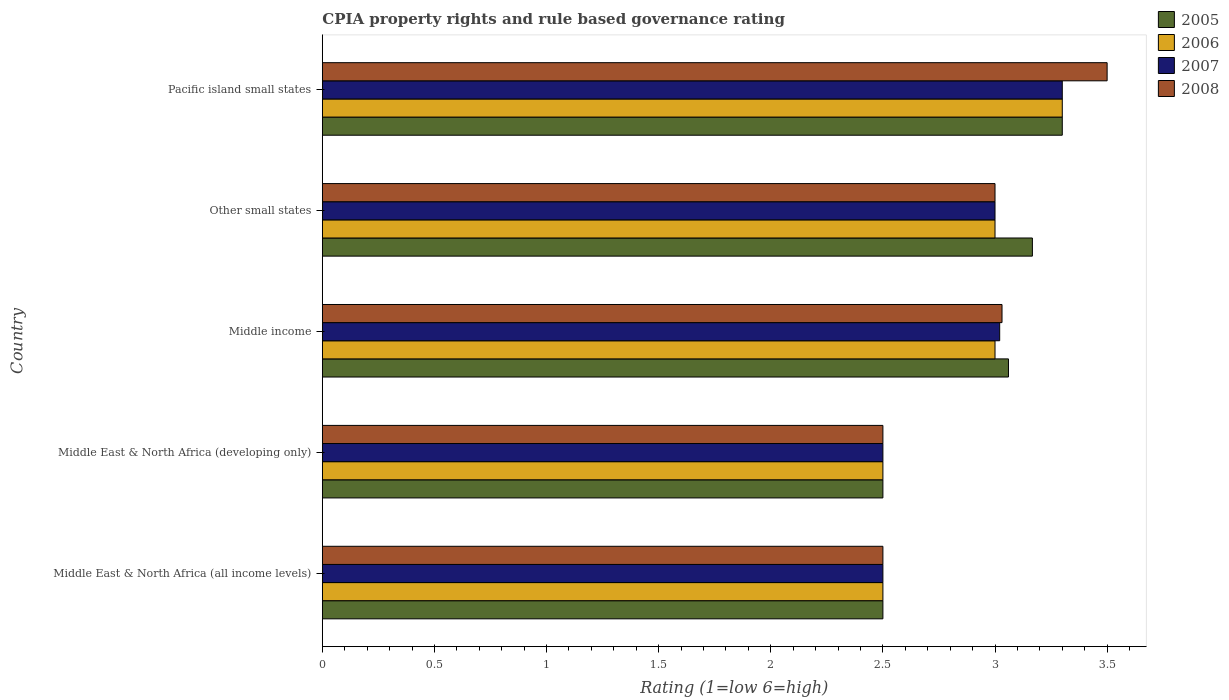How many groups of bars are there?
Your response must be concise. 5. Are the number of bars per tick equal to the number of legend labels?
Your answer should be very brief. Yes. How many bars are there on the 4th tick from the bottom?
Your response must be concise. 4. What is the label of the 3rd group of bars from the top?
Offer a terse response. Middle income. In how many cases, is the number of bars for a given country not equal to the number of legend labels?
Your response must be concise. 0. What is the CPIA rating in 2005 in Middle East & North Africa (developing only)?
Your response must be concise. 2.5. In which country was the CPIA rating in 2005 maximum?
Offer a terse response. Pacific island small states. In which country was the CPIA rating in 2006 minimum?
Provide a short and direct response. Middle East & North Africa (all income levels). What is the total CPIA rating in 2005 in the graph?
Offer a very short reply. 14.53. What is the average CPIA rating in 2007 per country?
Give a very brief answer. 2.86. In how many countries, is the CPIA rating in 2005 greater than 1.3 ?
Provide a short and direct response. 5. What is the ratio of the CPIA rating in 2008 in Middle East & North Africa (developing only) to that in Pacific island small states?
Make the answer very short. 0.71. What is the difference between the highest and the second highest CPIA rating in 2006?
Offer a terse response. 0.3. What is the difference between the highest and the lowest CPIA rating in 2006?
Your answer should be very brief. 0.8. Are the values on the major ticks of X-axis written in scientific E-notation?
Ensure brevity in your answer.  No. Does the graph contain any zero values?
Provide a succinct answer. No. How are the legend labels stacked?
Ensure brevity in your answer.  Vertical. What is the title of the graph?
Your answer should be compact. CPIA property rights and rule based governance rating. What is the label or title of the X-axis?
Make the answer very short. Rating (1=low 6=high). What is the Rating (1=low 6=high) in 2007 in Middle East & North Africa (all income levels)?
Offer a very short reply. 2.5. What is the Rating (1=low 6=high) in 2005 in Middle East & North Africa (developing only)?
Your response must be concise. 2.5. What is the Rating (1=low 6=high) of 2006 in Middle East & North Africa (developing only)?
Make the answer very short. 2.5. What is the Rating (1=low 6=high) in 2008 in Middle East & North Africa (developing only)?
Provide a short and direct response. 2.5. What is the Rating (1=low 6=high) of 2005 in Middle income?
Provide a short and direct response. 3.06. What is the Rating (1=low 6=high) of 2006 in Middle income?
Keep it short and to the point. 3. What is the Rating (1=low 6=high) of 2007 in Middle income?
Give a very brief answer. 3.02. What is the Rating (1=low 6=high) of 2008 in Middle income?
Your response must be concise. 3.03. What is the Rating (1=low 6=high) in 2005 in Other small states?
Provide a succinct answer. 3.17. What is the Rating (1=low 6=high) in 2006 in Other small states?
Provide a succinct answer. 3. What is the Rating (1=low 6=high) of 2007 in Other small states?
Keep it short and to the point. 3. What is the Rating (1=low 6=high) in 2006 in Pacific island small states?
Your answer should be compact. 3.3. Across all countries, what is the maximum Rating (1=low 6=high) of 2005?
Provide a succinct answer. 3.3. Across all countries, what is the maximum Rating (1=low 6=high) of 2006?
Your answer should be very brief. 3.3. Across all countries, what is the minimum Rating (1=low 6=high) of 2005?
Offer a very short reply. 2.5. Across all countries, what is the minimum Rating (1=low 6=high) in 2006?
Your answer should be very brief. 2.5. Across all countries, what is the minimum Rating (1=low 6=high) of 2008?
Make the answer very short. 2.5. What is the total Rating (1=low 6=high) of 2005 in the graph?
Provide a succinct answer. 14.53. What is the total Rating (1=low 6=high) of 2006 in the graph?
Keep it short and to the point. 14.3. What is the total Rating (1=low 6=high) in 2007 in the graph?
Offer a terse response. 14.32. What is the total Rating (1=low 6=high) in 2008 in the graph?
Your answer should be compact. 14.53. What is the difference between the Rating (1=low 6=high) in 2005 in Middle East & North Africa (all income levels) and that in Middle East & North Africa (developing only)?
Give a very brief answer. 0. What is the difference between the Rating (1=low 6=high) of 2006 in Middle East & North Africa (all income levels) and that in Middle East & North Africa (developing only)?
Provide a short and direct response. 0. What is the difference between the Rating (1=low 6=high) of 2008 in Middle East & North Africa (all income levels) and that in Middle East & North Africa (developing only)?
Make the answer very short. 0. What is the difference between the Rating (1=low 6=high) of 2005 in Middle East & North Africa (all income levels) and that in Middle income?
Provide a short and direct response. -0.56. What is the difference between the Rating (1=low 6=high) in 2006 in Middle East & North Africa (all income levels) and that in Middle income?
Offer a very short reply. -0.5. What is the difference between the Rating (1=low 6=high) in 2007 in Middle East & North Africa (all income levels) and that in Middle income?
Keep it short and to the point. -0.52. What is the difference between the Rating (1=low 6=high) in 2008 in Middle East & North Africa (all income levels) and that in Middle income?
Offer a terse response. -0.53. What is the difference between the Rating (1=low 6=high) in 2008 in Middle East & North Africa (all income levels) and that in Other small states?
Provide a short and direct response. -0.5. What is the difference between the Rating (1=low 6=high) in 2006 in Middle East & North Africa (all income levels) and that in Pacific island small states?
Offer a terse response. -0.8. What is the difference between the Rating (1=low 6=high) of 2007 in Middle East & North Africa (all income levels) and that in Pacific island small states?
Provide a succinct answer. -0.8. What is the difference between the Rating (1=low 6=high) in 2008 in Middle East & North Africa (all income levels) and that in Pacific island small states?
Offer a terse response. -1. What is the difference between the Rating (1=low 6=high) of 2005 in Middle East & North Africa (developing only) and that in Middle income?
Your answer should be very brief. -0.56. What is the difference between the Rating (1=low 6=high) of 2007 in Middle East & North Africa (developing only) and that in Middle income?
Your answer should be very brief. -0.52. What is the difference between the Rating (1=low 6=high) in 2008 in Middle East & North Africa (developing only) and that in Middle income?
Keep it short and to the point. -0.53. What is the difference between the Rating (1=low 6=high) in 2005 in Middle East & North Africa (developing only) and that in Other small states?
Ensure brevity in your answer.  -0.67. What is the difference between the Rating (1=low 6=high) in 2006 in Middle East & North Africa (developing only) and that in Other small states?
Your answer should be very brief. -0.5. What is the difference between the Rating (1=low 6=high) in 2007 in Middle East & North Africa (developing only) and that in Other small states?
Keep it short and to the point. -0.5. What is the difference between the Rating (1=low 6=high) in 2006 in Middle East & North Africa (developing only) and that in Pacific island small states?
Give a very brief answer. -0.8. What is the difference between the Rating (1=low 6=high) in 2008 in Middle East & North Africa (developing only) and that in Pacific island small states?
Provide a succinct answer. -1. What is the difference between the Rating (1=low 6=high) of 2005 in Middle income and that in Other small states?
Provide a short and direct response. -0.11. What is the difference between the Rating (1=low 6=high) of 2007 in Middle income and that in Other small states?
Offer a very short reply. 0.02. What is the difference between the Rating (1=low 6=high) of 2008 in Middle income and that in Other small states?
Offer a terse response. 0.03. What is the difference between the Rating (1=low 6=high) in 2005 in Middle income and that in Pacific island small states?
Offer a very short reply. -0.24. What is the difference between the Rating (1=low 6=high) of 2007 in Middle income and that in Pacific island small states?
Offer a very short reply. -0.28. What is the difference between the Rating (1=low 6=high) of 2008 in Middle income and that in Pacific island small states?
Make the answer very short. -0.47. What is the difference between the Rating (1=low 6=high) of 2005 in Other small states and that in Pacific island small states?
Your response must be concise. -0.13. What is the difference between the Rating (1=low 6=high) in 2008 in Other small states and that in Pacific island small states?
Your response must be concise. -0.5. What is the difference between the Rating (1=low 6=high) in 2005 in Middle East & North Africa (all income levels) and the Rating (1=low 6=high) in 2006 in Middle East & North Africa (developing only)?
Keep it short and to the point. 0. What is the difference between the Rating (1=low 6=high) in 2005 in Middle East & North Africa (all income levels) and the Rating (1=low 6=high) in 2008 in Middle East & North Africa (developing only)?
Offer a terse response. 0. What is the difference between the Rating (1=low 6=high) in 2006 in Middle East & North Africa (all income levels) and the Rating (1=low 6=high) in 2007 in Middle East & North Africa (developing only)?
Your answer should be compact. 0. What is the difference between the Rating (1=low 6=high) in 2006 in Middle East & North Africa (all income levels) and the Rating (1=low 6=high) in 2008 in Middle East & North Africa (developing only)?
Your response must be concise. 0. What is the difference between the Rating (1=low 6=high) of 2007 in Middle East & North Africa (all income levels) and the Rating (1=low 6=high) of 2008 in Middle East & North Africa (developing only)?
Give a very brief answer. 0. What is the difference between the Rating (1=low 6=high) of 2005 in Middle East & North Africa (all income levels) and the Rating (1=low 6=high) of 2007 in Middle income?
Your answer should be very brief. -0.52. What is the difference between the Rating (1=low 6=high) of 2005 in Middle East & North Africa (all income levels) and the Rating (1=low 6=high) of 2008 in Middle income?
Offer a terse response. -0.53. What is the difference between the Rating (1=low 6=high) of 2006 in Middle East & North Africa (all income levels) and the Rating (1=low 6=high) of 2007 in Middle income?
Your answer should be very brief. -0.52. What is the difference between the Rating (1=low 6=high) of 2006 in Middle East & North Africa (all income levels) and the Rating (1=low 6=high) of 2008 in Middle income?
Offer a very short reply. -0.53. What is the difference between the Rating (1=low 6=high) in 2007 in Middle East & North Africa (all income levels) and the Rating (1=low 6=high) in 2008 in Middle income?
Your answer should be very brief. -0.53. What is the difference between the Rating (1=low 6=high) of 2005 in Middle East & North Africa (all income levels) and the Rating (1=low 6=high) of 2006 in Other small states?
Your answer should be very brief. -0.5. What is the difference between the Rating (1=low 6=high) in 2005 in Middle East & North Africa (all income levels) and the Rating (1=low 6=high) in 2008 in Other small states?
Ensure brevity in your answer.  -0.5. What is the difference between the Rating (1=low 6=high) of 2006 in Middle East & North Africa (all income levels) and the Rating (1=low 6=high) of 2007 in Other small states?
Offer a terse response. -0.5. What is the difference between the Rating (1=low 6=high) in 2006 in Middle East & North Africa (all income levels) and the Rating (1=low 6=high) in 2008 in Other small states?
Your answer should be very brief. -0.5. What is the difference between the Rating (1=low 6=high) in 2005 in Middle East & North Africa (all income levels) and the Rating (1=low 6=high) in 2007 in Pacific island small states?
Offer a very short reply. -0.8. What is the difference between the Rating (1=low 6=high) in 2005 in Middle East & North Africa (all income levels) and the Rating (1=low 6=high) in 2008 in Pacific island small states?
Offer a very short reply. -1. What is the difference between the Rating (1=low 6=high) in 2006 in Middle East & North Africa (all income levels) and the Rating (1=low 6=high) in 2008 in Pacific island small states?
Keep it short and to the point. -1. What is the difference between the Rating (1=low 6=high) in 2005 in Middle East & North Africa (developing only) and the Rating (1=low 6=high) in 2006 in Middle income?
Provide a short and direct response. -0.5. What is the difference between the Rating (1=low 6=high) in 2005 in Middle East & North Africa (developing only) and the Rating (1=low 6=high) in 2007 in Middle income?
Offer a terse response. -0.52. What is the difference between the Rating (1=low 6=high) of 2005 in Middle East & North Africa (developing only) and the Rating (1=low 6=high) of 2008 in Middle income?
Offer a very short reply. -0.53. What is the difference between the Rating (1=low 6=high) of 2006 in Middle East & North Africa (developing only) and the Rating (1=low 6=high) of 2007 in Middle income?
Keep it short and to the point. -0.52. What is the difference between the Rating (1=low 6=high) in 2006 in Middle East & North Africa (developing only) and the Rating (1=low 6=high) in 2008 in Middle income?
Your response must be concise. -0.53. What is the difference between the Rating (1=low 6=high) in 2007 in Middle East & North Africa (developing only) and the Rating (1=low 6=high) in 2008 in Middle income?
Make the answer very short. -0.53. What is the difference between the Rating (1=low 6=high) of 2006 in Middle East & North Africa (developing only) and the Rating (1=low 6=high) of 2007 in Other small states?
Your response must be concise. -0.5. What is the difference between the Rating (1=low 6=high) of 2005 in Middle East & North Africa (developing only) and the Rating (1=low 6=high) of 2006 in Pacific island small states?
Give a very brief answer. -0.8. What is the difference between the Rating (1=low 6=high) in 2005 in Middle East & North Africa (developing only) and the Rating (1=low 6=high) in 2007 in Pacific island small states?
Keep it short and to the point. -0.8. What is the difference between the Rating (1=low 6=high) of 2006 in Middle East & North Africa (developing only) and the Rating (1=low 6=high) of 2008 in Pacific island small states?
Provide a short and direct response. -1. What is the difference between the Rating (1=low 6=high) of 2005 in Middle income and the Rating (1=low 6=high) of 2008 in Other small states?
Give a very brief answer. 0.06. What is the difference between the Rating (1=low 6=high) in 2006 in Middle income and the Rating (1=low 6=high) in 2008 in Other small states?
Provide a succinct answer. 0. What is the difference between the Rating (1=low 6=high) of 2007 in Middle income and the Rating (1=low 6=high) of 2008 in Other small states?
Give a very brief answer. 0.02. What is the difference between the Rating (1=low 6=high) of 2005 in Middle income and the Rating (1=low 6=high) of 2006 in Pacific island small states?
Offer a terse response. -0.24. What is the difference between the Rating (1=low 6=high) of 2005 in Middle income and the Rating (1=low 6=high) of 2007 in Pacific island small states?
Provide a succinct answer. -0.24. What is the difference between the Rating (1=low 6=high) in 2005 in Middle income and the Rating (1=low 6=high) in 2008 in Pacific island small states?
Provide a short and direct response. -0.44. What is the difference between the Rating (1=low 6=high) of 2006 in Middle income and the Rating (1=low 6=high) of 2007 in Pacific island small states?
Your answer should be very brief. -0.3. What is the difference between the Rating (1=low 6=high) in 2007 in Middle income and the Rating (1=low 6=high) in 2008 in Pacific island small states?
Provide a succinct answer. -0.48. What is the difference between the Rating (1=low 6=high) in 2005 in Other small states and the Rating (1=low 6=high) in 2006 in Pacific island small states?
Keep it short and to the point. -0.13. What is the difference between the Rating (1=low 6=high) in 2005 in Other small states and the Rating (1=low 6=high) in 2007 in Pacific island small states?
Offer a very short reply. -0.13. What is the difference between the Rating (1=low 6=high) of 2005 in Other small states and the Rating (1=low 6=high) of 2008 in Pacific island small states?
Your response must be concise. -0.33. What is the difference between the Rating (1=low 6=high) in 2006 in Other small states and the Rating (1=low 6=high) in 2008 in Pacific island small states?
Offer a very short reply. -0.5. What is the average Rating (1=low 6=high) in 2005 per country?
Make the answer very short. 2.91. What is the average Rating (1=low 6=high) in 2006 per country?
Give a very brief answer. 2.86. What is the average Rating (1=low 6=high) in 2007 per country?
Your answer should be compact. 2.86. What is the average Rating (1=low 6=high) of 2008 per country?
Offer a very short reply. 2.91. What is the difference between the Rating (1=low 6=high) of 2005 and Rating (1=low 6=high) of 2006 in Middle East & North Africa (all income levels)?
Provide a succinct answer. 0. What is the difference between the Rating (1=low 6=high) in 2005 and Rating (1=low 6=high) in 2007 in Middle East & North Africa (all income levels)?
Your response must be concise. 0. What is the difference between the Rating (1=low 6=high) of 2006 and Rating (1=low 6=high) of 2008 in Middle East & North Africa (all income levels)?
Provide a succinct answer. 0. What is the difference between the Rating (1=low 6=high) of 2005 and Rating (1=low 6=high) of 2006 in Middle East & North Africa (developing only)?
Ensure brevity in your answer.  0. What is the difference between the Rating (1=low 6=high) in 2006 and Rating (1=low 6=high) in 2007 in Middle East & North Africa (developing only)?
Keep it short and to the point. 0. What is the difference between the Rating (1=low 6=high) in 2007 and Rating (1=low 6=high) in 2008 in Middle East & North Africa (developing only)?
Provide a short and direct response. 0. What is the difference between the Rating (1=low 6=high) in 2005 and Rating (1=low 6=high) in 2006 in Middle income?
Make the answer very short. 0.06. What is the difference between the Rating (1=low 6=high) in 2005 and Rating (1=low 6=high) in 2007 in Middle income?
Keep it short and to the point. 0.04. What is the difference between the Rating (1=low 6=high) of 2005 and Rating (1=low 6=high) of 2008 in Middle income?
Offer a terse response. 0.03. What is the difference between the Rating (1=low 6=high) in 2006 and Rating (1=low 6=high) in 2007 in Middle income?
Offer a terse response. -0.02. What is the difference between the Rating (1=low 6=high) of 2006 and Rating (1=low 6=high) of 2008 in Middle income?
Provide a succinct answer. -0.03. What is the difference between the Rating (1=low 6=high) of 2007 and Rating (1=low 6=high) of 2008 in Middle income?
Give a very brief answer. -0.01. What is the difference between the Rating (1=low 6=high) of 2005 and Rating (1=low 6=high) of 2006 in Other small states?
Provide a succinct answer. 0.17. What is the difference between the Rating (1=low 6=high) of 2005 and Rating (1=low 6=high) of 2007 in Other small states?
Offer a very short reply. 0.17. What is the difference between the Rating (1=low 6=high) in 2005 and Rating (1=low 6=high) in 2008 in Other small states?
Offer a very short reply. 0.17. What is the difference between the Rating (1=low 6=high) of 2005 and Rating (1=low 6=high) of 2006 in Pacific island small states?
Ensure brevity in your answer.  0. What is the difference between the Rating (1=low 6=high) in 2006 and Rating (1=low 6=high) in 2007 in Pacific island small states?
Make the answer very short. 0. What is the difference between the Rating (1=low 6=high) of 2006 and Rating (1=low 6=high) of 2008 in Pacific island small states?
Offer a very short reply. -0.2. What is the difference between the Rating (1=low 6=high) of 2007 and Rating (1=low 6=high) of 2008 in Pacific island small states?
Provide a succinct answer. -0.2. What is the ratio of the Rating (1=low 6=high) of 2005 in Middle East & North Africa (all income levels) to that in Middle East & North Africa (developing only)?
Offer a very short reply. 1. What is the ratio of the Rating (1=low 6=high) of 2007 in Middle East & North Africa (all income levels) to that in Middle East & North Africa (developing only)?
Provide a short and direct response. 1. What is the ratio of the Rating (1=low 6=high) of 2008 in Middle East & North Africa (all income levels) to that in Middle East & North Africa (developing only)?
Keep it short and to the point. 1. What is the ratio of the Rating (1=low 6=high) in 2005 in Middle East & North Africa (all income levels) to that in Middle income?
Offer a terse response. 0.82. What is the ratio of the Rating (1=low 6=high) of 2006 in Middle East & North Africa (all income levels) to that in Middle income?
Your answer should be very brief. 0.83. What is the ratio of the Rating (1=low 6=high) of 2007 in Middle East & North Africa (all income levels) to that in Middle income?
Offer a very short reply. 0.83. What is the ratio of the Rating (1=low 6=high) of 2008 in Middle East & North Africa (all income levels) to that in Middle income?
Make the answer very short. 0.82. What is the ratio of the Rating (1=low 6=high) in 2005 in Middle East & North Africa (all income levels) to that in Other small states?
Give a very brief answer. 0.79. What is the ratio of the Rating (1=low 6=high) of 2005 in Middle East & North Africa (all income levels) to that in Pacific island small states?
Provide a succinct answer. 0.76. What is the ratio of the Rating (1=low 6=high) in 2006 in Middle East & North Africa (all income levels) to that in Pacific island small states?
Your answer should be very brief. 0.76. What is the ratio of the Rating (1=low 6=high) in 2007 in Middle East & North Africa (all income levels) to that in Pacific island small states?
Offer a terse response. 0.76. What is the ratio of the Rating (1=low 6=high) of 2008 in Middle East & North Africa (all income levels) to that in Pacific island small states?
Offer a very short reply. 0.71. What is the ratio of the Rating (1=low 6=high) of 2005 in Middle East & North Africa (developing only) to that in Middle income?
Offer a very short reply. 0.82. What is the ratio of the Rating (1=low 6=high) in 2006 in Middle East & North Africa (developing only) to that in Middle income?
Offer a terse response. 0.83. What is the ratio of the Rating (1=low 6=high) of 2007 in Middle East & North Africa (developing only) to that in Middle income?
Offer a very short reply. 0.83. What is the ratio of the Rating (1=low 6=high) in 2008 in Middle East & North Africa (developing only) to that in Middle income?
Give a very brief answer. 0.82. What is the ratio of the Rating (1=low 6=high) of 2005 in Middle East & North Africa (developing only) to that in Other small states?
Provide a succinct answer. 0.79. What is the ratio of the Rating (1=low 6=high) of 2008 in Middle East & North Africa (developing only) to that in Other small states?
Offer a terse response. 0.83. What is the ratio of the Rating (1=low 6=high) in 2005 in Middle East & North Africa (developing only) to that in Pacific island small states?
Your answer should be compact. 0.76. What is the ratio of the Rating (1=low 6=high) of 2006 in Middle East & North Africa (developing only) to that in Pacific island small states?
Your response must be concise. 0.76. What is the ratio of the Rating (1=low 6=high) of 2007 in Middle East & North Africa (developing only) to that in Pacific island small states?
Your answer should be very brief. 0.76. What is the ratio of the Rating (1=low 6=high) of 2008 in Middle East & North Africa (developing only) to that in Pacific island small states?
Your answer should be very brief. 0.71. What is the ratio of the Rating (1=low 6=high) of 2005 in Middle income to that in Other small states?
Your response must be concise. 0.97. What is the ratio of the Rating (1=low 6=high) in 2006 in Middle income to that in Other small states?
Your response must be concise. 1. What is the ratio of the Rating (1=low 6=high) in 2007 in Middle income to that in Other small states?
Ensure brevity in your answer.  1.01. What is the ratio of the Rating (1=low 6=high) of 2008 in Middle income to that in Other small states?
Offer a very short reply. 1.01. What is the ratio of the Rating (1=low 6=high) in 2005 in Middle income to that in Pacific island small states?
Make the answer very short. 0.93. What is the ratio of the Rating (1=low 6=high) of 2006 in Middle income to that in Pacific island small states?
Your response must be concise. 0.91. What is the ratio of the Rating (1=low 6=high) in 2007 in Middle income to that in Pacific island small states?
Make the answer very short. 0.92. What is the ratio of the Rating (1=low 6=high) of 2008 in Middle income to that in Pacific island small states?
Provide a short and direct response. 0.87. What is the ratio of the Rating (1=low 6=high) of 2005 in Other small states to that in Pacific island small states?
Your response must be concise. 0.96. What is the ratio of the Rating (1=low 6=high) of 2006 in Other small states to that in Pacific island small states?
Ensure brevity in your answer.  0.91. What is the ratio of the Rating (1=low 6=high) in 2007 in Other small states to that in Pacific island small states?
Give a very brief answer. 0.91. What is the difference between the highest and the second highest Rating (1=low 6=high) of 2005?
Offer a very short reply. 0.13. What is the difference between the highest and the second highest Rating (1=low 6=high) of 2007?
Keep it short and to the point. 0.28. What is the difference between the highest and the second highest Rating (1=low 6=high) in 2008?
Give a very brief answer. 0.47. 